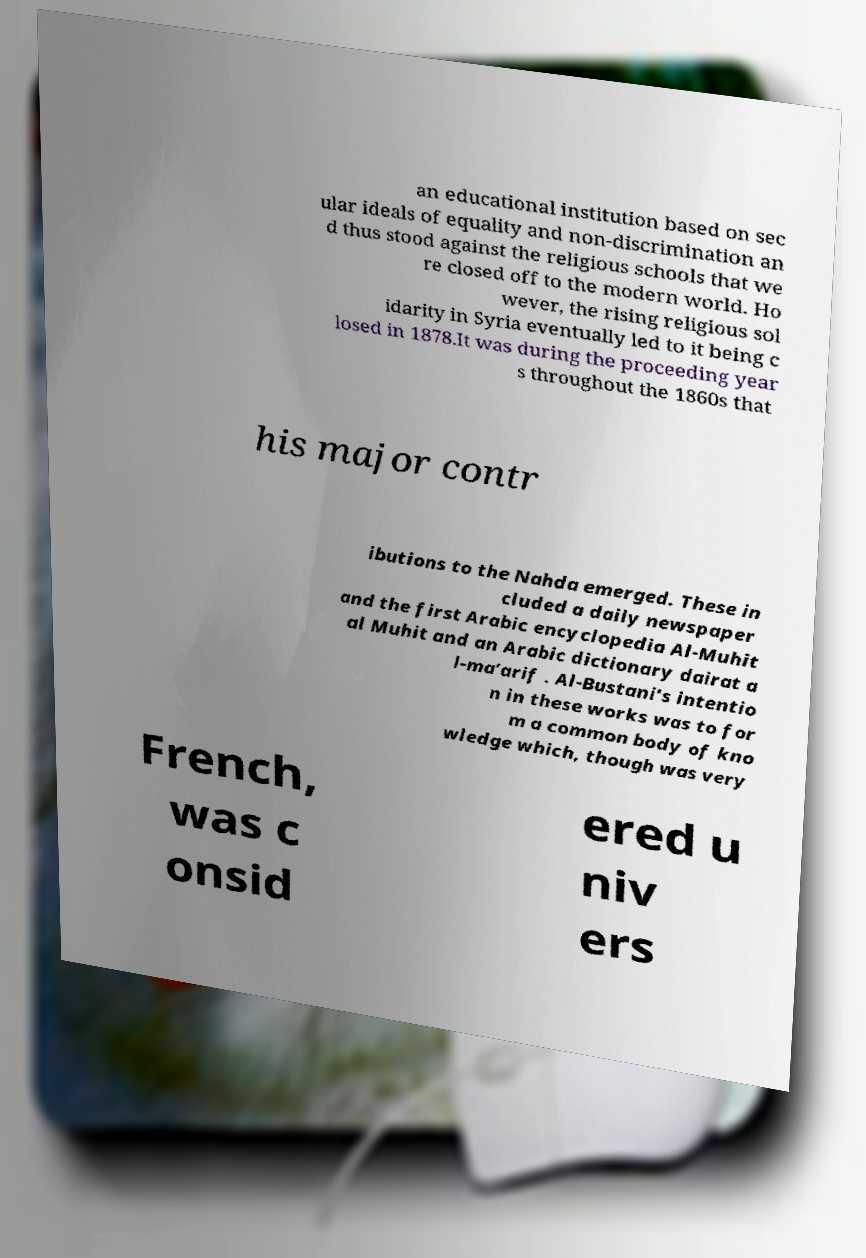Please identify and transcribe the text found in this image. an educational institution based on sec ular ideals of equality and non-discrimination an d thus stood against the religious schools that we re closed off to the modern world. Ho wever, the rising religious sol idarity in Syria eventually led to it being c losed in 1878.It was during the proceeding year s throughout the 1860s that his major contr ibutions to the Nahda emerged. These in cluded a daily newspaper and the first Arabic encyclopedia Al-Muhit al Muhit and an Arabic dictionary dairat a l-ma’arif . Al-Bustani's intentio n in these works was to for m a common body of kno wledge which, though was very French, was c onsid ered u niv ers 